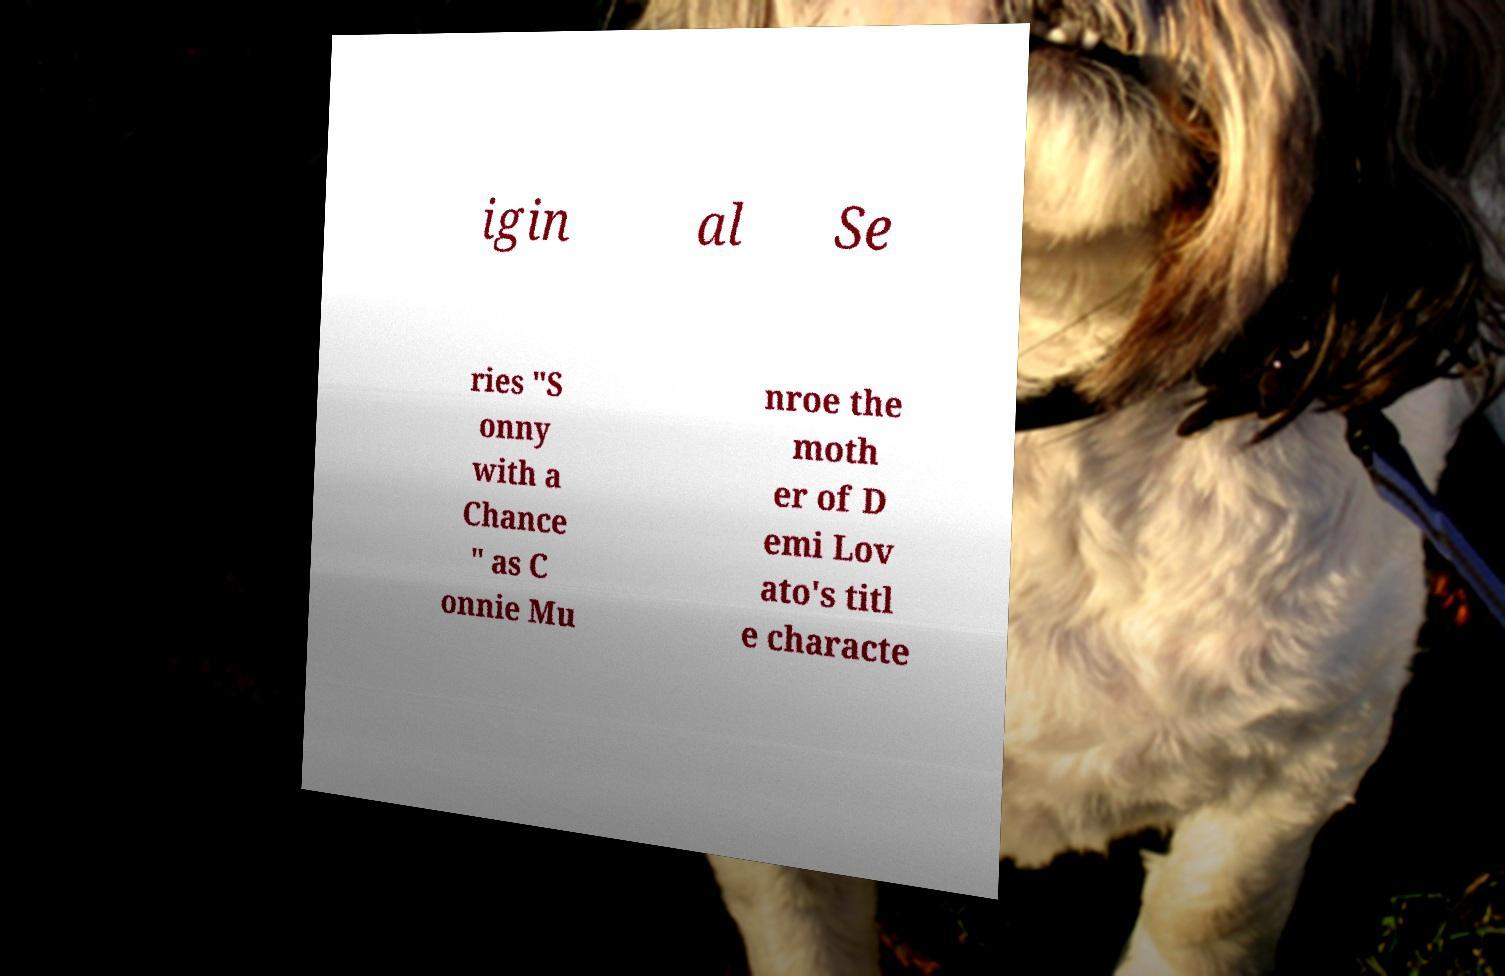Can you read and provide the text displayed in the image?This photo seems to have some interesting text. Can you extract and type it out for me? igin al Se ries "S onny with a Chance " as C onnie Mu nroe the moth er of D emi Lov ato's titl e characte 